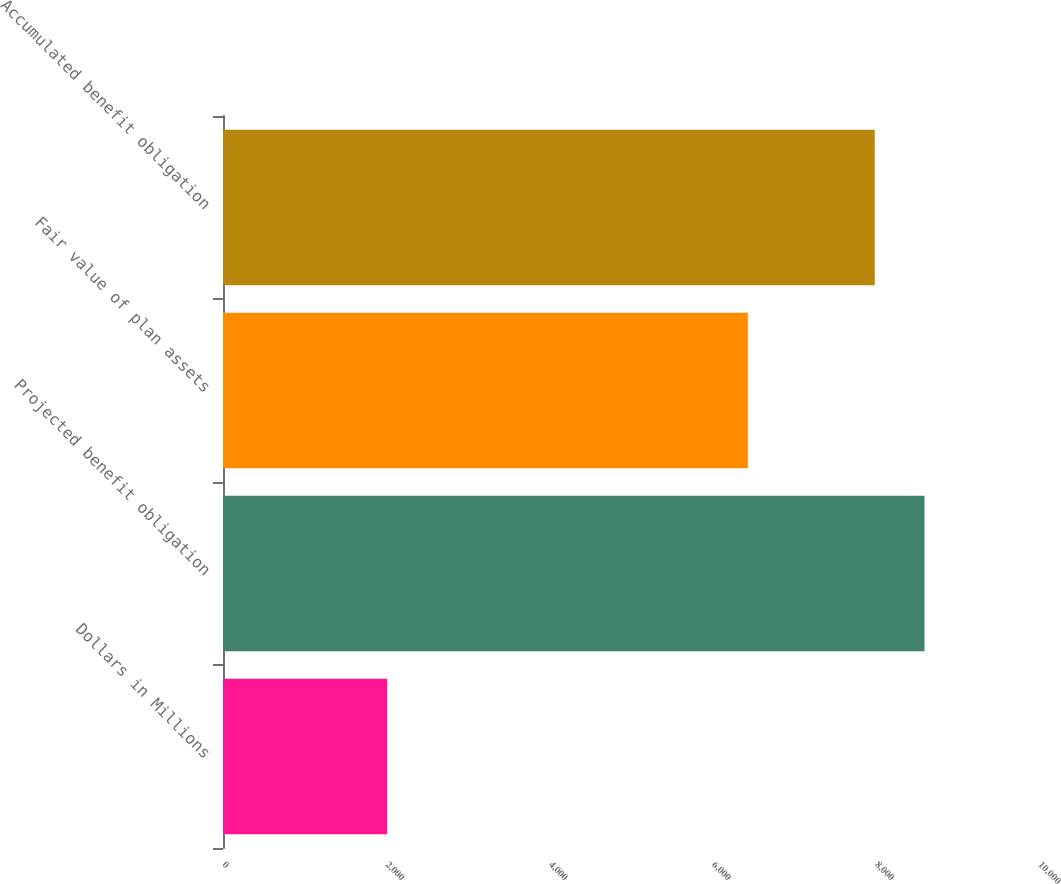Convert chart to OTSL. <chart><loc_0><loc_0><loc_500><loc_500><bar_chart><fcel>Dollars in Millions<fcel>Projected benefit obligation<fcel>Fair value of plan assets<fcel>Accumulated benefit obligation<nl><fcel>2012<fcel>8597<fcel>6432<fcel>7987<nl></chart> 